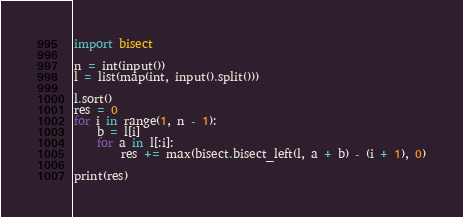Convert code to text. <code><loc_0><loc_0><loc_500><loc_500><_Python_>import bisect

n = int(input())
l = list(map(int, input().split()))

l.sort()
res = 0
for i in range(1, n - 1):
    b = l[i]
    for a in l[:i]:
        res += max(bisect.bisect_left(l, a + b) - (i + 1), 0)

print(res)
</code> 